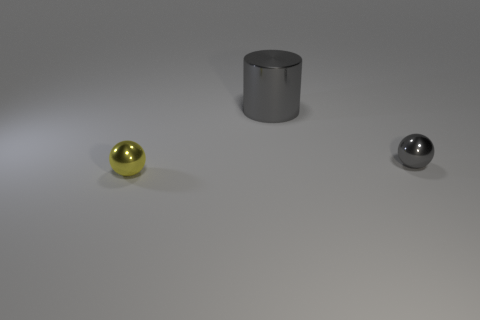Add 2 shiny balls. How many objects exist? 5 Subtract all cylinders. How many objects are left? 2 Subtract 0 yellow cubes. How many objects are left? 3 Subtract all cylinders. Subtract all gray shiny balls. How many objects are left? 1 Add 3 balls. How many balls are left? 5 Add 3 yellow metal spheres. How many yellow metal spheres exist? 4 